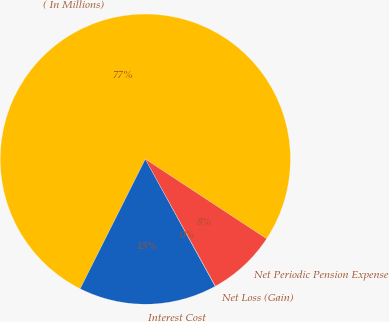Convert chart. <chart><loc_0><loc_0><loc_500><loc_500><pie_chart><fcel>( In Millions)<fcel>Interest Cost<fcel>Net Loss (Gain)<fcel>Net Periodic Pension Expense<nl><fcel>76.84%<fcel>15.4%<fcel>0.04%<fcel>7.72%<nl></chart> 